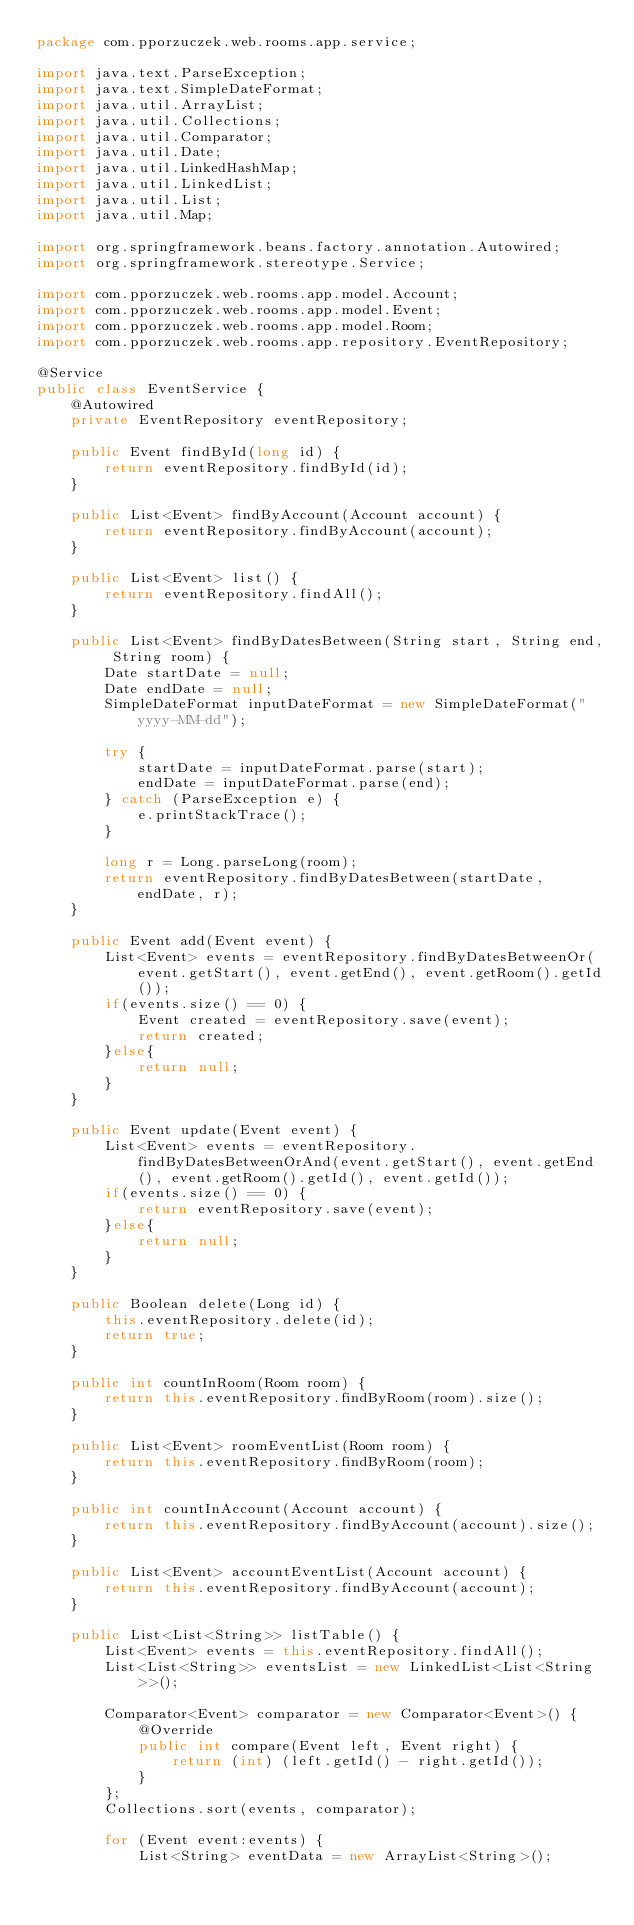Convert code to text. <code><loc_0><loc_0><loc_500><loc_500><_Java_>package com.pporzuczek.web.rooms.app.service;

import java.text.ParseException;
import java.text.SimpleDateFormat;
import java.util.ArrayList;
import java.util.Collections;
import java.util.Comparator;
import java.util.Date;
import java.util.LinkedHashMap;
import java.util.LinkedList;
import java.util.List;
import java.util.Map;

import org.springframework.beans.factory.annotation.Autowired;
import org.springframework.stereotype.Service;

import com.pporzuczek.web.rooms.app.model.Account;
import com.pporzuczek.web.rooms.app.model.Event;
import com.pporzuczek.web.rooms.app.model.Room;
import com.pporzuczek.web.rooms.app.repository.EventRepository;

@Service
public class EventService {
	@Autowired
	private EventRepository eventRepository;
	
	public Event findById(long id) {
		return eventRepository.findById(id);
	}
	
	public List<Event> findByAccount(Account account) {
		return eventRepository.findByAccount(account);
	}
	
	public List<Event> list() {
		return eventRepository.findAll();
	}
	
	public List<Event> findByDatesBetween(String start, String end, String room) {
		Date startDate = null;
		Date endDate = null;
		SimpleDateFormat inputDateFormat = new SimpleDateFormat("yyyy-MM-dd");
		
		try {
			startDate = inputDateFormat.parse(start);
			endDate = inputDateFormat.parse(end);
		} catch (ParseException e) {
			e.printStackTrace();
		}
		
		long r = Long.parseLong(room);
		return eventRepository.findByDatesBetween(startDate, endDate, r);
	}
	
	public Event add(Event event) {
		List<Event> events = eventRepository.findByDatesBetweenOr(event.getStart(), event.getEnd(), event.getRoom().getId());
		if(events.size() == 0) {
			Event created = eventRepository.save(event);
			return created; 
		}else{
			return null;
		}
	}
	
	public Event update(Event event) {
		List<Event> events = eventRepository.findByDatesBetweenOrAnd(event.getStart(), event.getEnd(), event.getRoom().getId(), event.getId());
		if(events.size() == 0) {
			return eventRepository.save(event);
		}else{
			return null;
		}
	}
	
    public Boolean delete(Long id) {
        this.eventRepository.delete(id);
        return true;
    }
	
	public int countInRoom(Room room) {
		return this.eventRepository.findByRoom(room).size();
	}
	
	public List<Event> roomEventList(Room room) {
		return this.eventRepository.findByRoom(room);
	}
	
	public int countInAccount(Account account) {
		return this.eventRepository.findByAccount(account).size();
	}
	
	public List<Event> accountEventList(Account account) {
		return this.eventRepository.findByAccount(account);
	}
	
	public List<List<String>> listTable() {
		List<Event> events = this.eventRepository.findAll();
	    List<List<String>> eventsList = new LinkedList<List<String>>();
	    
	    Comparator<Event> comparator = new Comparator<Event>() {
		    @Override
		    public int compare(Event left, Event right) {
		        return (int) (left.getId() - right.getId());
		    }
		};
		Collections.sort(events, comparator);
	    
	    for (Event event:events) {
	    	List<String> eventData = new ArrayList<String>();</code> 